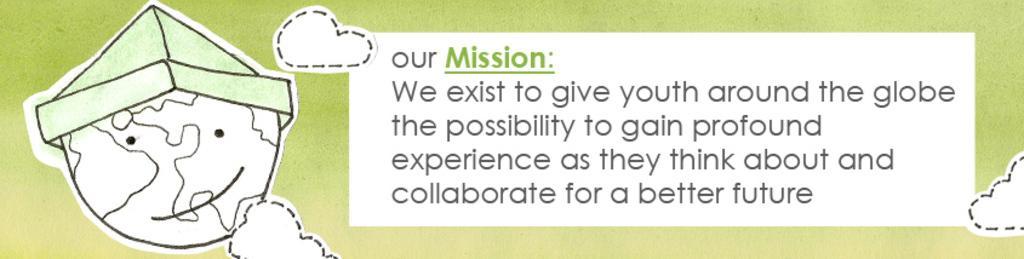How would you summarize this image in a sentence or two? In the image in the center we can see one poster. On the poster,it is written as "Our Mission". 